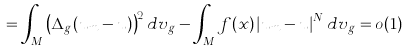<formula> <loc_0><loc_0><loc_500><loc_500>= \int _ { M } \left ( \Delta _ { g } ( u _ { m } - u ) \right ) ^ { 2 } d v _ { g } - \int _ { M } f ( x ) \left | u _ { m } - u \right | ^ { N } d v _ { g } = o ( 1 )</formula> 